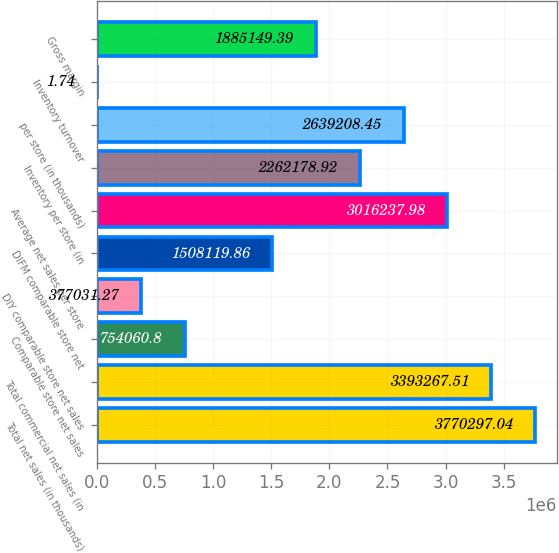Convert chart. <chart><loc_0><loc_0><loc_500><loc_500><bar_chart><fcel>Total net sales (in thousands)<fcel>Total commercial net sales (in<fcel>Comparable store net sales<fcel>DIY comparable store net sales<fcel>DIFM comparable store net<fcel>Average net sales per store<fcel>Inventory per store (in<fcel>per store (in thousands)<fcel>Inventory turnover<fcel>Gross margin<nl><fcel>3.7703e+06<fcel>3.39327e+06<fcel>754061<fcel>377031<fcel>1.50812e+06<fcel>3.01624e+06<fcel>2.26218e+06<fcel>2.63921e+06<fcel>1.74<fcel>1.88515e+06<nl></chart> 